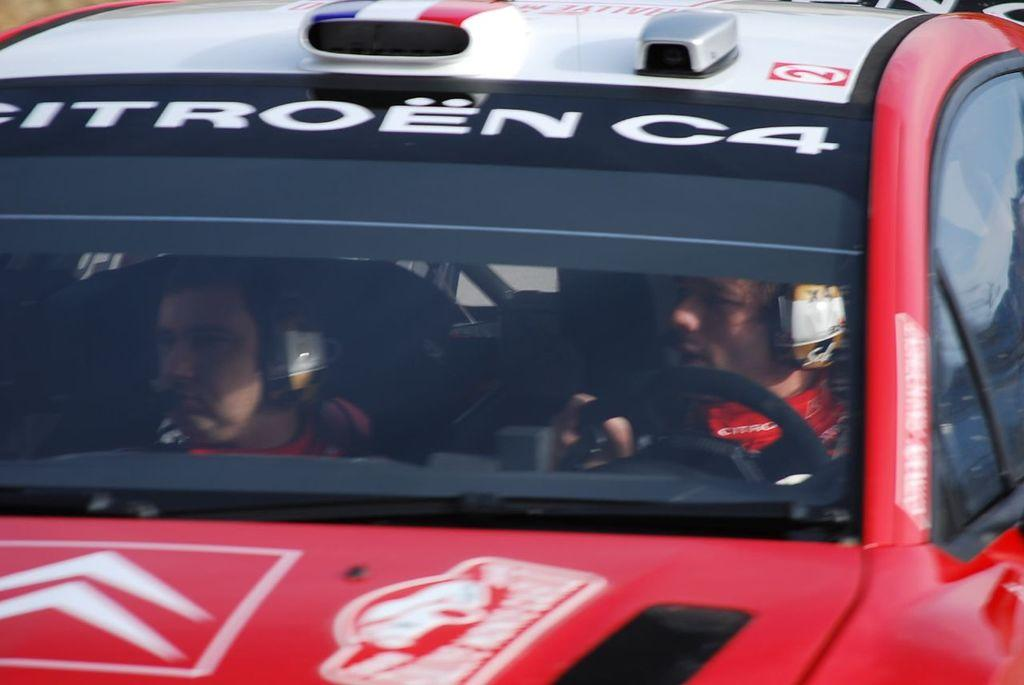How many people are in the image? There are two persons in the image. What are the persons doing in the image? The persons are sitting in a red color car. What can be seen on the car besides the persons? There is text on the car. What else is visible in the image? There are other objects visible in the image. Can you see any snails crawling on the car in the image? There are no snails visible in the image. What type of rifle is being used by one of the persons in the image? There is no rifle present in the image; the persons are sitting in a car. 